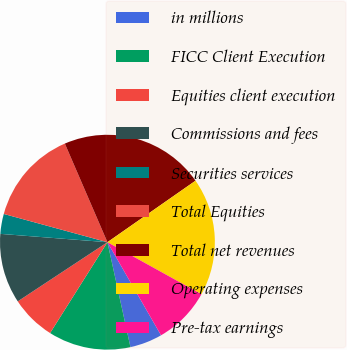Convert chart. <chart><loc_0><loc_0><loc_500><loc_500><pie_chart><fcel>in millions<fcel>FICC Client Execution<fcel>Equities client execution<fcel>Commissions and fees<fcel>Securities services<fcel>Total Equities<fcel>Total net revenues<fcel>Operating expenses<fcel>Pre-tax earnings<nl><fcel>4.88%<fcel>12.4%<fcel>6.76%<fcel>10.52%<fcel>3.0%<fcel>14.28%<fcel>21.79%<fcel>17.75%<fcel>8.64%<nl></chart> 